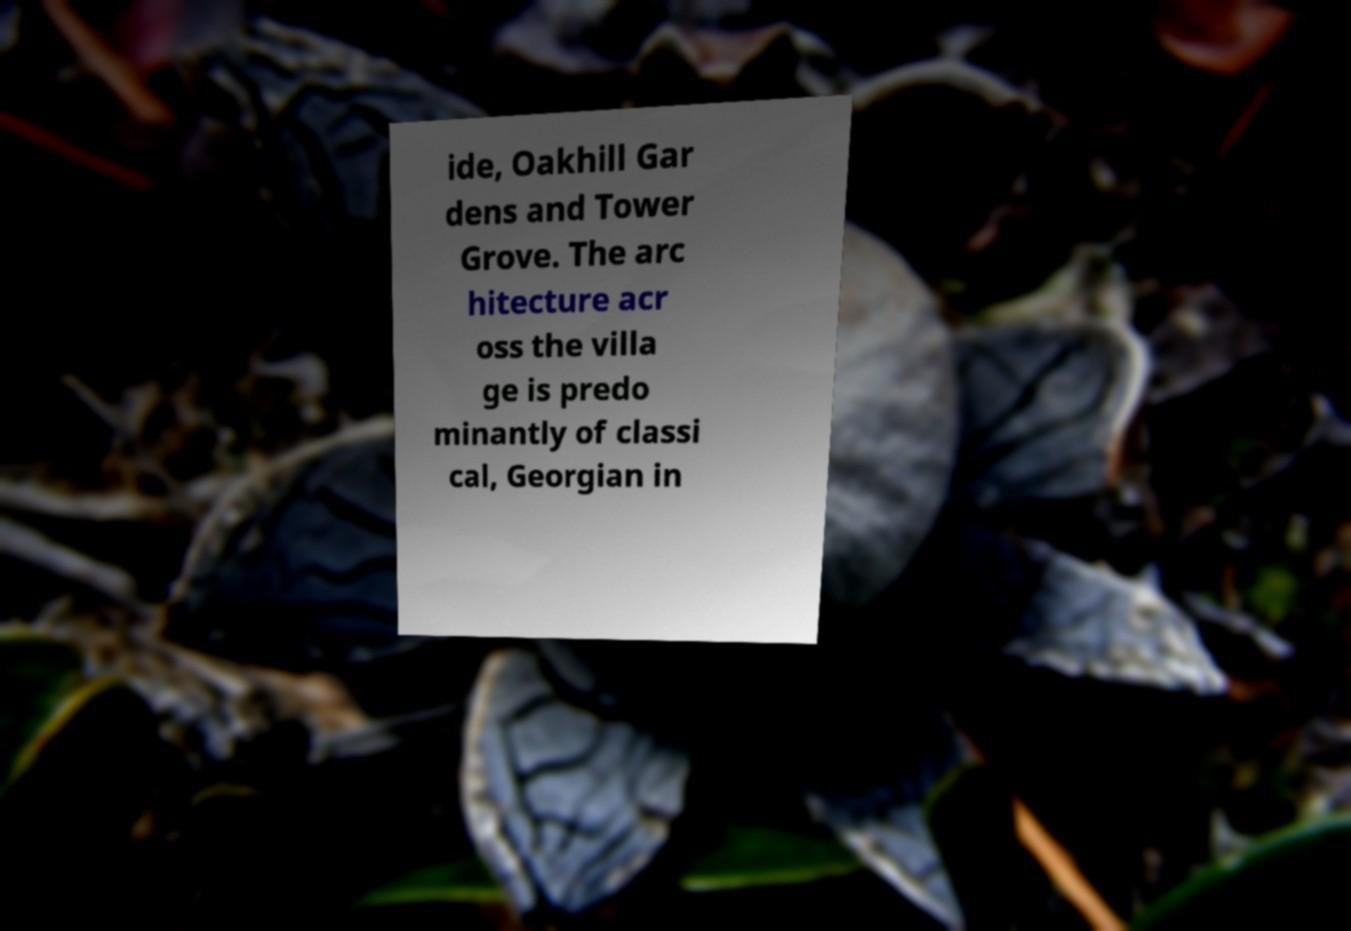Could you assist in decoding the text presented in this image and type it out clearly? ide, Oakhill Gar dens and Tower Grove. The arc hitecture acr oss the villa ge is predo minantly of classi cal, Georgian in 